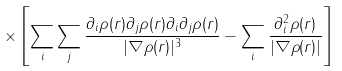Convert formula to latex. <formula><loc_0><loc_0><loc_500><loc_500>\times \left [ \sum _ { i } \sum _ { j } \frac { \partial _ { i } \rho ( { r } ) \partial _ { j } \rho ( { r } ) \partial _ { i } \partial _ { j } \rho ( { r } ) } { | \nabla \rho ( { r } ) | ^ { 3 } } - \sum _ { i } \frac { \partial _ { i } ^ { 2 } \rho ( { r } ) } { | \nabla \rho ( { r } ) | } \right ]</formula> 